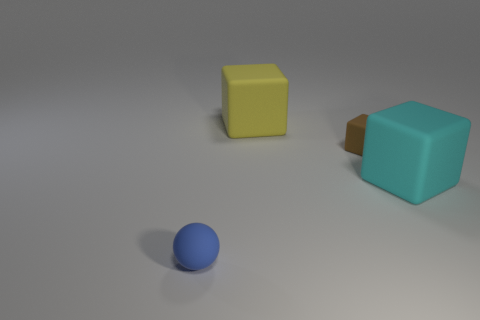What number of other things are the same shape as the yellow object?
Give a very brief answer. 2. Is the number of tiny rubber things right of the cyan thing greater than the number of tiny blue things?
Give a very brief answer. No. The big rubber thing that is behind the rubber block that is in front of the small rubber thing that is on the right side of the matte sphere is what shape?
Your answer should be very brief. Cube. There is a large matte object that is to the left of the cyan block; does it have the same shape as the tiny rubber thing behind the big cyan cube?
Your answer should be very brief. Yes. Are there any other things that are the same size as the yellow block?
Offer a terse response. Yes. How many cubes are either cyan objects or tiny rubber objects?
Your response must be concise. 2. Do the large cyan block and the large yellow cube have the same material?
Your response must be concise. Yes. How many other things are the same color as the sphere?
Offer a terse response. 0. What is the shape of the tiny rubber object that is on the right side of the blue matte sphere?
Offer a very short reply. Cube. What number of things are either small matte cubes or tiny blue rubber cylinders?
Offer a very short reply. 1. 